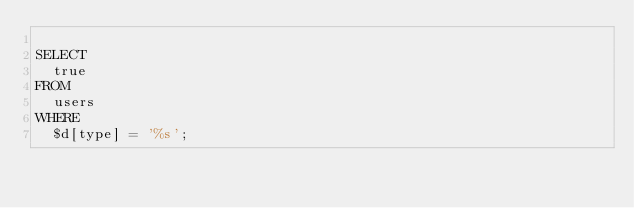<code> <loc_0><loc_0><loc_500><loc_500><_SQL_>
SELECT
  true
FROM
  users
WHERE
  $d[type] = '%s';</code> 